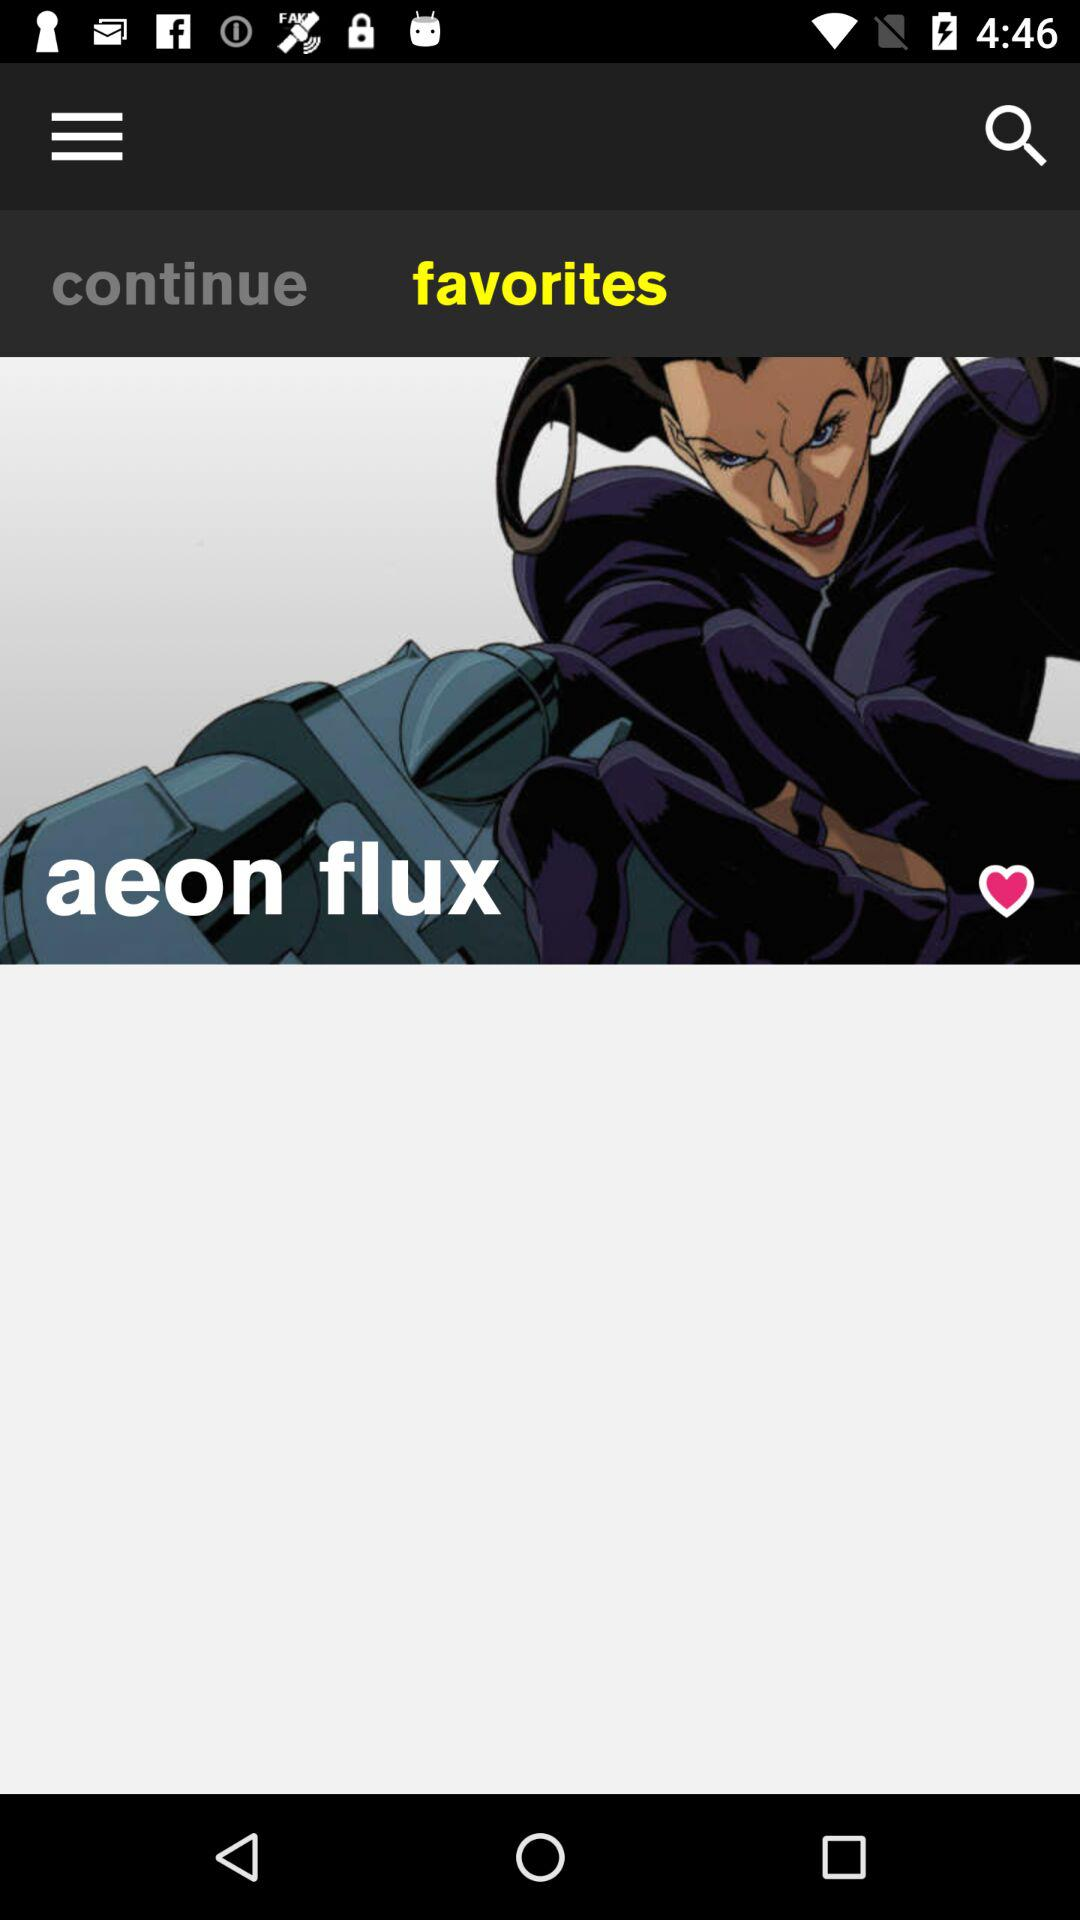Which tab is selected? The selected tab is "favorites". 